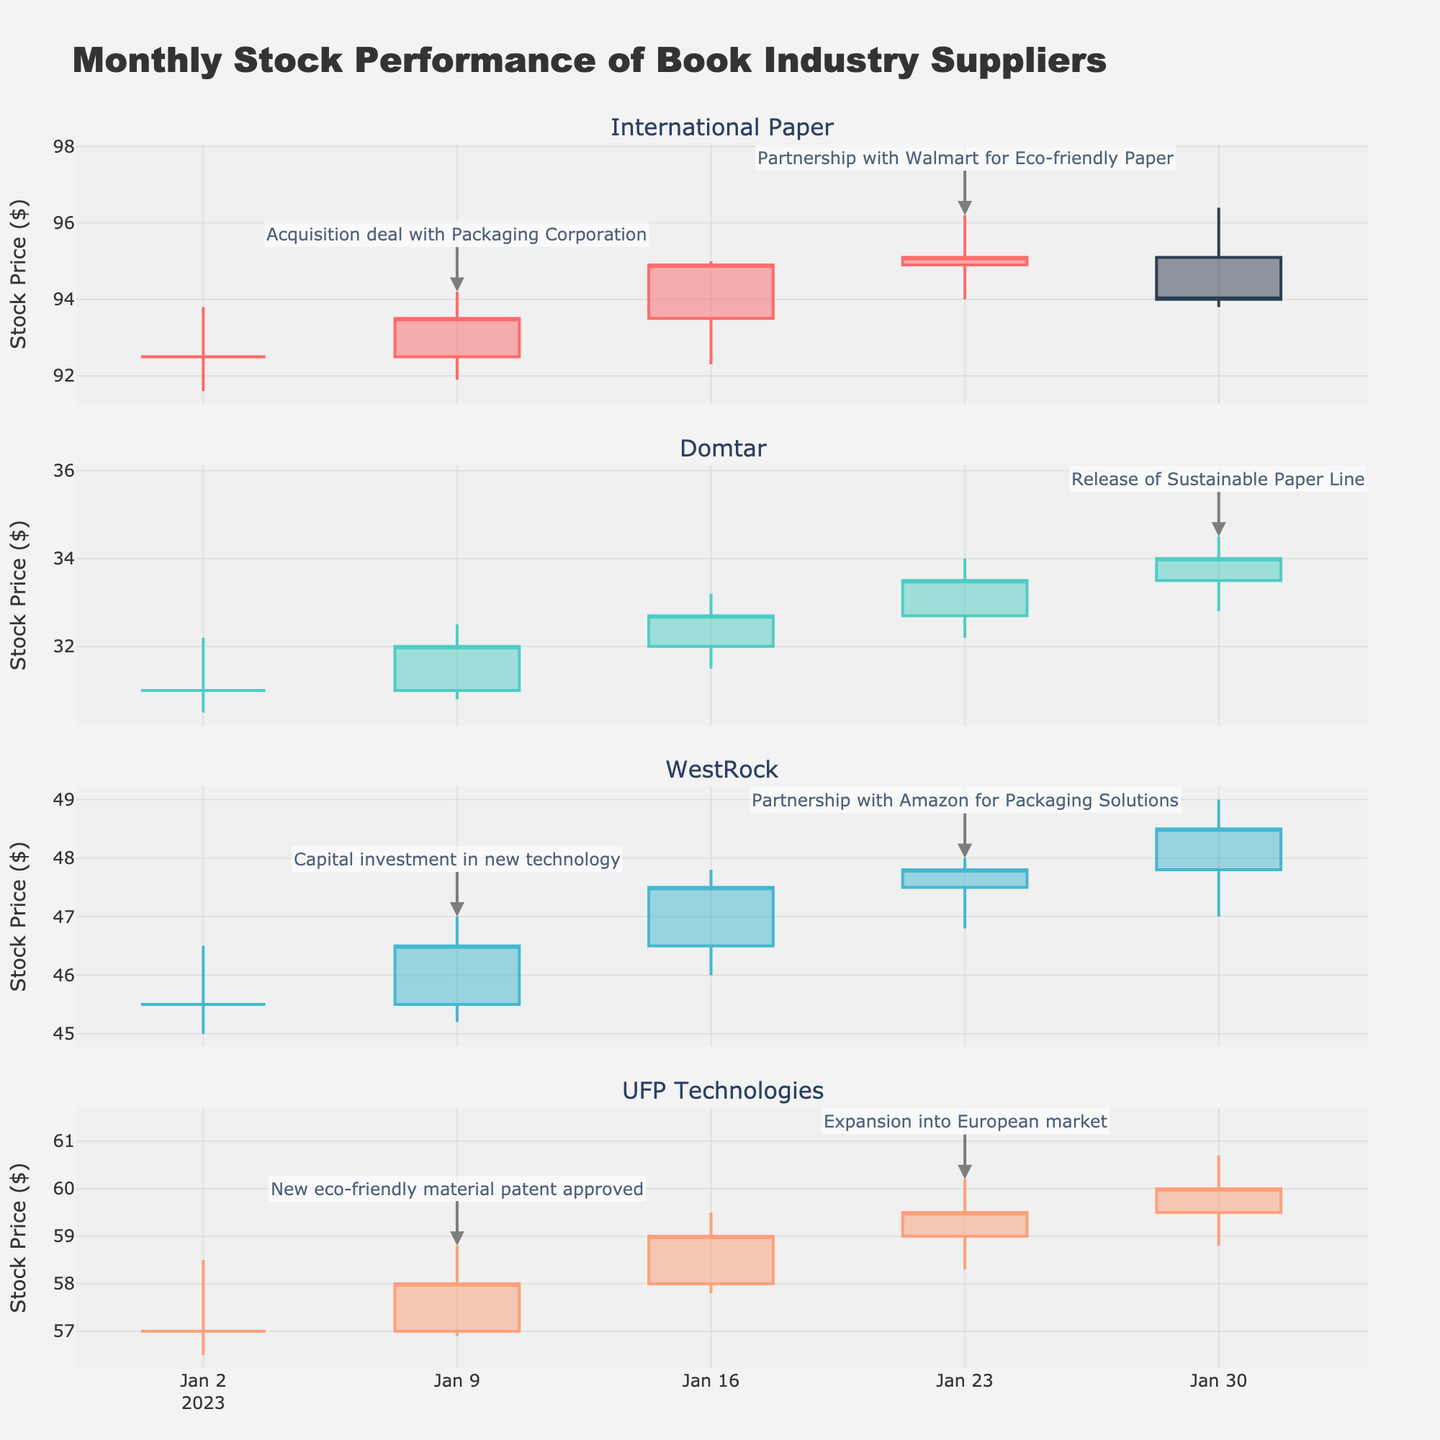What's the title of the figure? The title of the figure is generally located at the top center of the plot and provides a summary of what the figure represents. Here, the title "Monthly Stock Performance of Book Industry Suppliers" summarises that the figure shows the monthly stock prices for suppliers in the book industry.
Answer: Monthly Stock Performance of Book Industry Suppliers How many companies' stocks are displayed in the plot? To determine the number, count the subplot titles or traces where each title represents a different company. In this specific figure, there are subplots for each company: International Paper, Domtar, WestRock, and UFP Technologies.
Answer: 4 What kind of event is annotated for WestRock on January 23rd? Look for the annotation marked by arrows next to the candlestick on January 23rd for WestRock. The annotation points to notable market events.
Answer: Partnership with Amazon for Packaging Solutions Which company had a stock price increase from January 2nd to January 30th? Examine the opening and closing prices from January 2nd and January 30th for each company. A price increase is identified by the closing price on January 30th being higher than the opening price on January 2nd. UFP Technologies shows an increase from $57.00 to $60.00.
Answer: UFP Technologies What was the highest price achieved by Domtar in January? Look for the highest 'High' value in the candlestick plots for Domtar in January. The highest price is indicated by the peak of the candlesticks. The highest price Domtar reached in January was $34.00.
Answer: $34.00 How does the stock volume of International Paper on January 9th compare to January 2nd? Compare the 'Volume' values on January 9th and January 2nd for International Paper. January 9th has 1,320,000 and January 2nd has 1,200,000, indicating an increase.
Answer: Increased What was the trend in UFP Technologies' stock price throughout January? Evaluate the candlestick plots for UFP Technologies across the dates in January. The trend can be identified by the direction of the overall price movement. The stock price for UFP Technologies shows a trend of increasing from $57.00 to $60.00 throughout the month.
Answer: Increasing Which company's stock did not close higher than it opened on January 30th? Evaluate the opening and closing prices for January 30th across all companies. The comparison shows that International Paper closed lower ($94.00) than it opened ($95.10) on the specified date.
Answer: International Paper What significant event likely influenced International Paper’s stock increase in the week of January 23rd? Check the annotations for International Paper in that week. The annotated event points to "Partnership with Walmart for Eco-friendly Paper," likely influencing the increase.
Answer: Partnership with Walmart for Eco-friendly Paper 